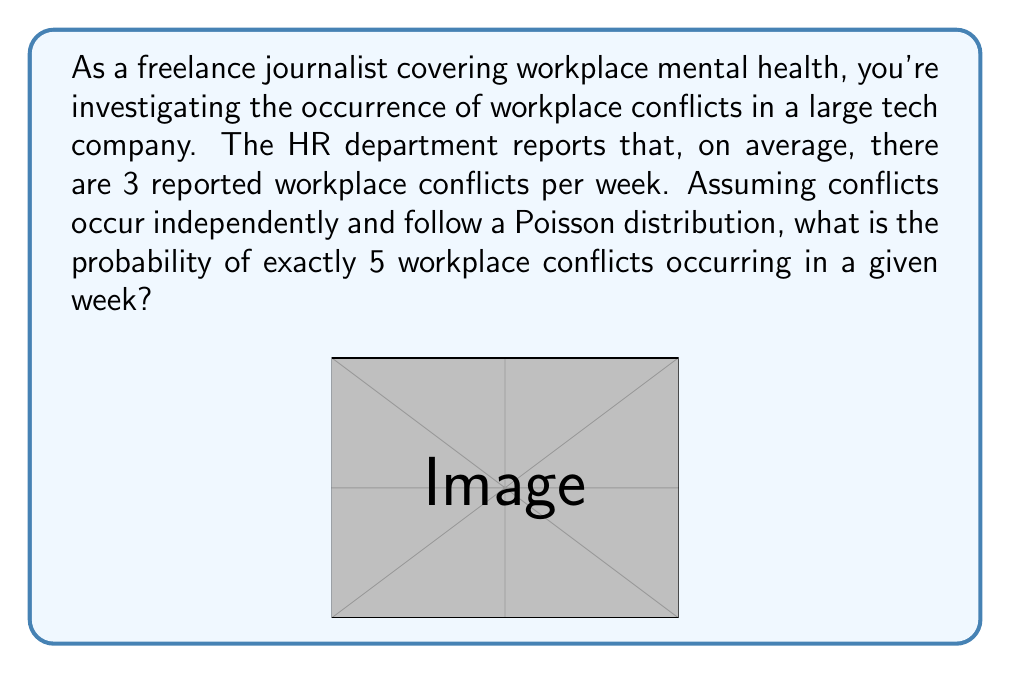Help me with this question. To solve this problem, we'll use the Poisson distribution formula:

$$P(X = k) = \frac{e^{-\lambda} \lambda^k}{k!}$$

Where:
$\lambda$ = average rate of occurrence
$k$ = number of events we're calculating the probability for
$e$ = Euler's number (approximately 2.71828)

Given:
$\lambda = 3$ (average of 3 conflicts per week)
$k = 5$ (we're calculating the probability of exactly 5 conflicts)

Step 1: Plug the values into the formula
$$P(X = 5) = \frac{e^{-3} 3^5}{5!}$$

Step 2: Calculate $3^5$
$3^5 = 243$

Step 3: Calculate $5!$
$5! = 5 \times 4 \times 3 \times 2 \times 1 = 120$

Step 4: Calculate $e^{-3}$
$e^{-3} \approx 0.0497870684$

Step 5: Put it all together
$$P(X = 5) = \frac{0.0497870684 \times 243}{120}$$

Step 6: Perform the final calculation
$$P(X = 5) \approx 0.1008$$

Therefore, the probability of exactly 5 workplace conflicts occurring in a given week is approximately 0.1008 or 10.08%.
Answer: $0.1008$ or $10.08\%$ 